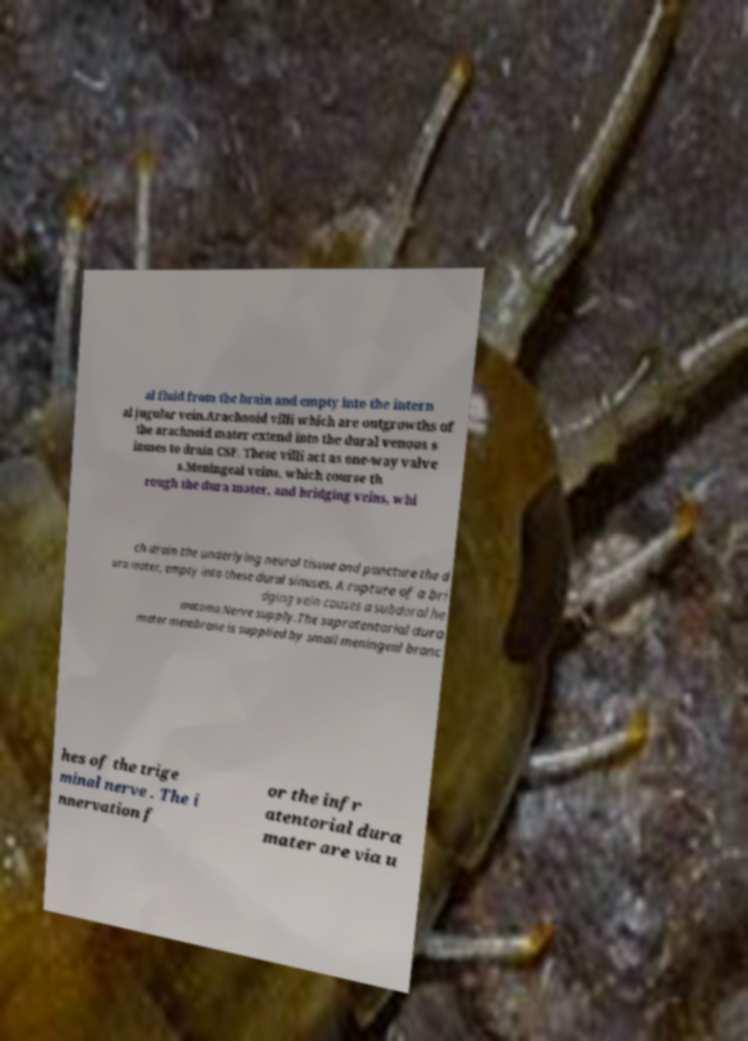There's text embedded in this image that I need extracted. Can you transcribe it verbatim? al fluid from the brain and empty into the intern al jugular vein.Arachnoid villi which are outgrowths of the arachnoid mater extend into the dural venous s inuses to drain CSF. These villi act as one-way valve s.Meningeal veins, which course th rough the dura mater, and bridging veins, whi ch drain the underlying neural tissue and puncture the d ura mater, empty into these dural sinuses. A rupture of a bri dging vein causes a subdural he matoma.Nerve supply.The supratentorial dura mater membrane is supplied by small meningeal branc hes of the trige minal nerve . The i nnervation f or the infr atentorial dura mater are via u 